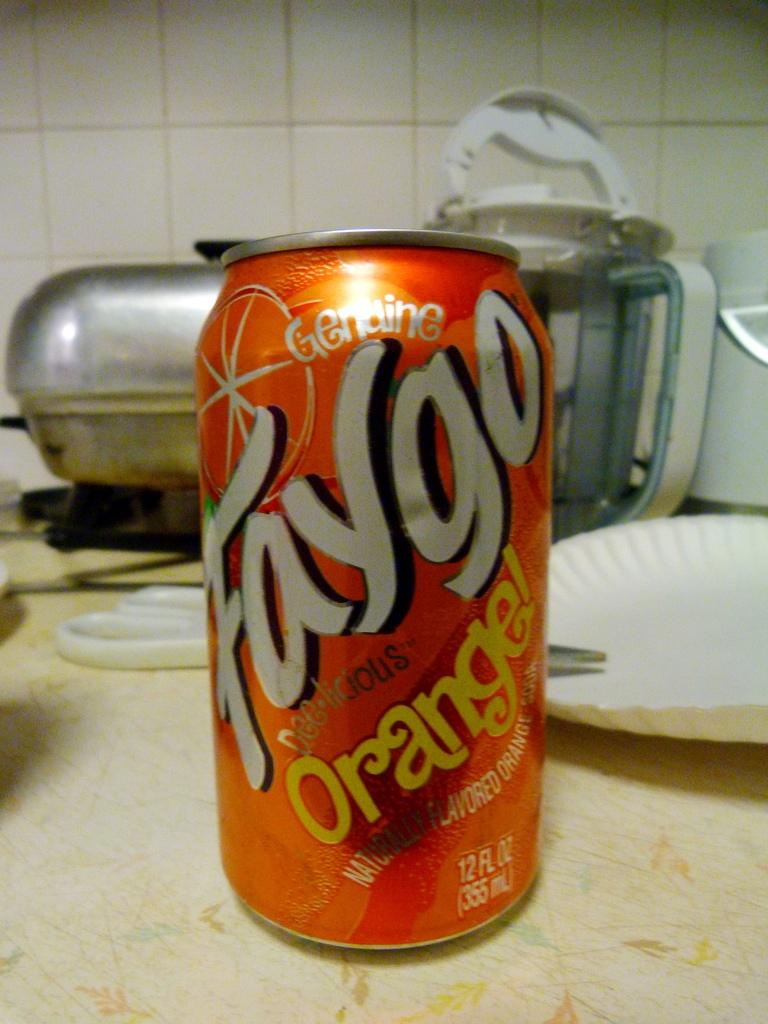<image>
Summarize the visual content of the image. A can of soda that says Faygo Orange is on a counter by a paper plate. 